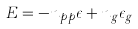Convert formula to latex. <formula><loc_0><loc_0><loc_500><loc_500>E = - n _ { p p } \epsilon + n _ { g } \epsilon _ { g }</formula> 